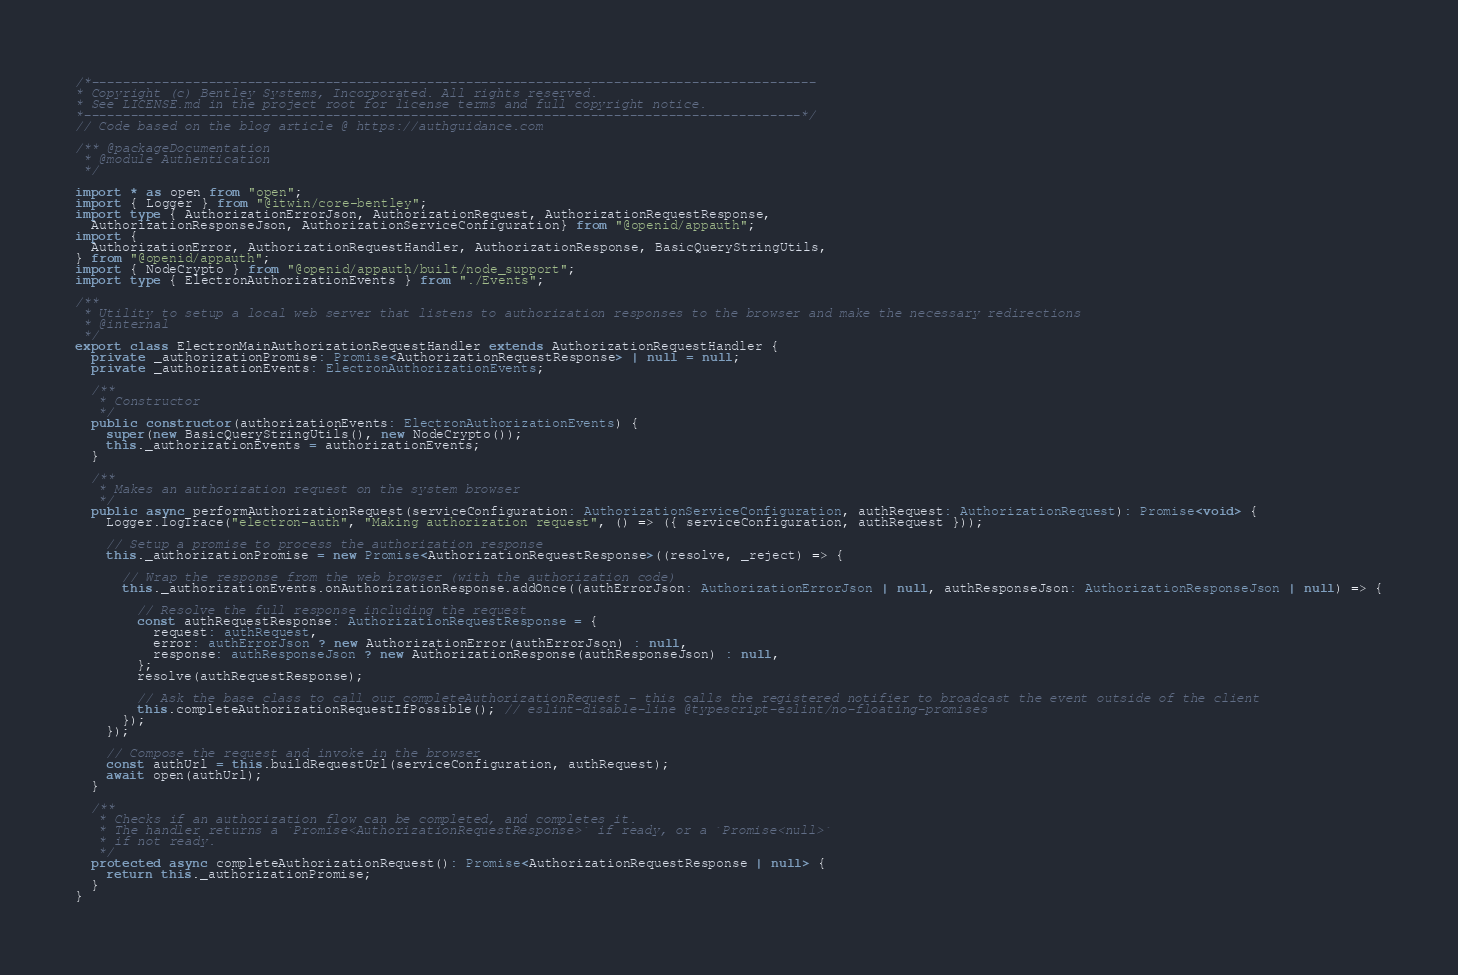<code> <loc_0><loc_0><loc_500><loc_500><_TypeScript_>/*---------------------------------------------------------------------------------------------
* Copyright (c) Bentley Systems, Incorporated. All rights reserved.
* See LICENSE.md in the project root for license terms and full copyright notice.
*--------------------------------------------------------------------------------------------*/
// Code based on the blog article @ https://authguidance.com

/** @packageDocumentation
 * @module Authentication
 */

import * as open from "open";
import { Logger } from "@itwin/core-bentley";
import type { AuthorizationErrorJson, AuthorizationRequest, AuthorizationRequestResponse,
  AuthorizationResponseJson, AuthorizationServiceConfiguration} from "@openid/appauth";
import {
  AuthorizationError, AuthorizationRequestHandler, AuthorizationResponse, BasicQueryStringUtils,
} from "@openid/appauth";
import { NodeCrypto } from "@openid/appauth/built/node_support";
import type { ElectronAuthorizationEvents } from "./Events";

/**
 * Utility to setup a local web server that listens to authorization responses to the browser and make the necessary redirections
 * @internal
 */
export class ElectronMainAuthorizationRequestHandler extends AuthorizationRequestHandler {
  private _authorizationPromise: Promise<AuthorizationRequestResponse> | null = null;
  private _authorizationEvents: ElectronAuthorizationEvents;

  /**
   * Constructor
   */
  public constructor(authorizationEvents: ElectronAuthorizationEvents) {
    super(new BasicQueryStringUtils(), new NodeCrypto());
    this._authorizationEvents = authorizationEvents;
  }

  /**
   * Makes an authorization request on the system browser
   */
  public async performAuthorizationRequest(serviceConfiguration: AuthorizationServiceConfiguration, authRequest: AuthorizationRequest): Promise<void> {
    Logger.logTrace("electron-auth", "Making authorization request", () => ({ serviceConfiguration, authRequest }));

    // Setup a promise to process the authorization response
    this._authorizationPromise = new Promise<AuthorizationRequestResponse>((resolve, _reject) => {

      // Wrap the response from the web browser (with the authorization code)
      this._authorizationEvents.onAuthorizationResponse.addOnce((authErrorJson: AuthorizationErrorJson | null, authResponseJson: AuthorizationResponseJson | null) => {

        // Resolve the full response including the request
        const authRequestResponse: AuthorizationRequestResponse = {
          request: authRequest,
          error: authErrorJson ? new AuthorizationError(authErrorJson) : null,
          response: authResponseJson ? new AuthorizationResponse(authResponseJson) : null,
        };
        resolve(authRequestResponse);

        // Ask the base class to call our completeAuthorizationRequest - this calls the registered notifier to broadcast the event outside of the client
        this.completeAuthorizationRequestIfPossible(); // eslint-disable-line @typescript-eslint/no-floating-promises
      });
    });

    // Compose the request and invoke in the browser
    const authUrl = this.buildRequestUrl(serviceConfiguration, authRequest);
    await open(authUrl);
  }

  /**
   * Checks if an authorization flow can be completed, and completes it.
   * The handler returns a `Promise<AuthorizationRequestResponse>` if ready, or a `Promise<null>`
   * if not ready.
   */
  protected async completeAuthorizationRequest(): Promise<AuthorizationRequestResponse | null> {
    return this._authorizationPromise;
  }
}
</code> 